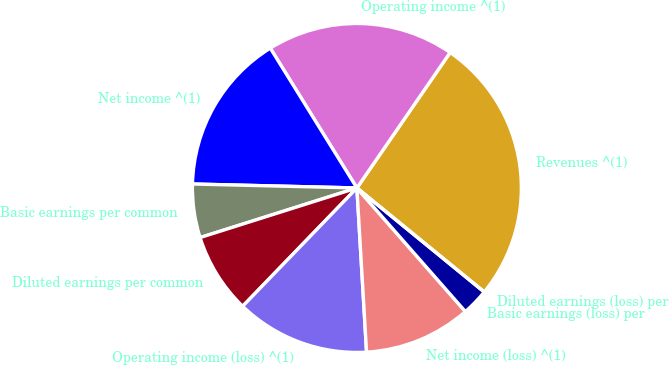<chart> <loc_0><loc_0><loc_500><loc_500><pie_chart><fcel>Revenues ^(1)<fcel>Operating income ^(1)<fcel>Net income ^(1)<fcel>Basic earnings per common<fcel>Diluted earnings per common<fcel>Operating income (loss) ^(1)<fcel>Net income (loss) ^(1)<fcel>Basic earnings (loss) per<fcel>Diluted earnings (loss) per<nl><fcel>26.31%<fcel>18.42%<fcel>15.79%<fcel>5.26%<fcel>7.9%<fcel>13.16%<fcel>10.53%<fcel>2.63%<fcel>0.0%<nl></chart> 